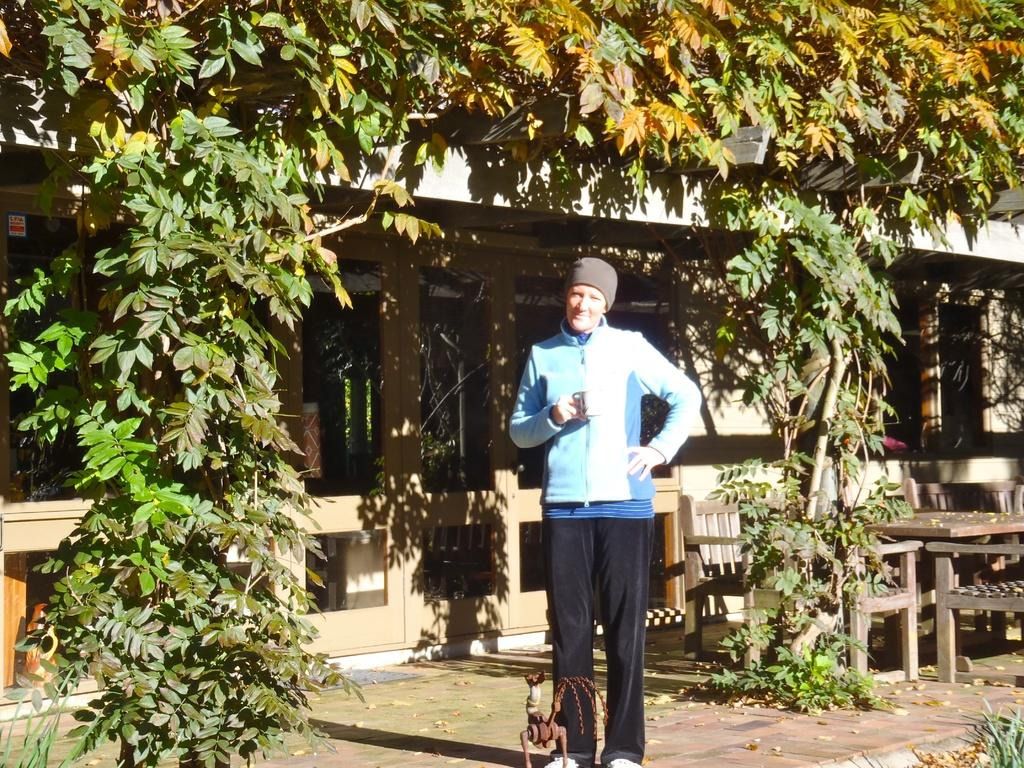What is the person in the image doing? The person is standing on the path in the image. What is the person holding in the image? The person is holding a cup. What can be seen in the background of the image? There is a house, plants, and a table and chairs visible in the background of the image. What type of bone is the person chewing on in the image? There is no bone present in the image; the person is holding a cup. 